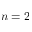Convert formula to latex. <formula><loc_0><loc_0><loc_500><loc_500>n = 2</formula> 